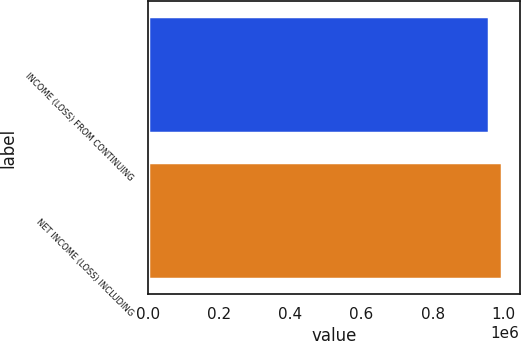Convert chart to OTSL. <chart><loc_0><loc_0><loc_500><loc_500><bar_chart><fcel>INCOME (LOSS) FROM CONTINUING<fcel>NET INCOME (LOSS) INCLUDING<nl><fcel>957062<fcel>994661<nl></chart> 